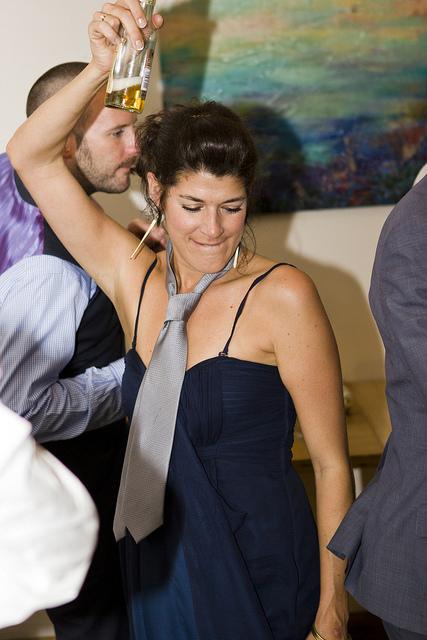What is she drinking?
Short answer required. Beer. Is the woman wearing an evening dress?
Be succinct. Yes. Is she wearing sunglasses?
Keep it brief. No. Is she wearing earrings?
Concise answer only. Yes. What article of male clothing is this woman wearing?
Answer briefly. Tie. Does this woman look excited?
Short answer required. Yes. What is the lady licking?
Write a very short answer. Lips. 